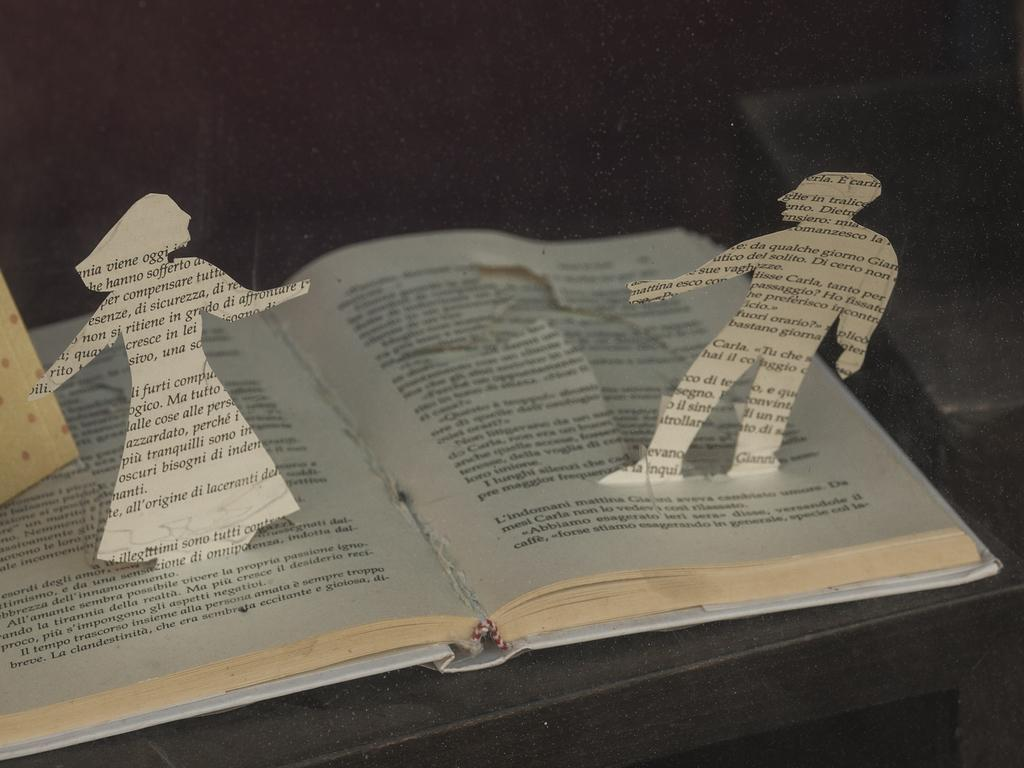Provide a one-sentence caption for the provided image. A cutout of a book made to look like a man and a woman with the man having the work Carla on him. 